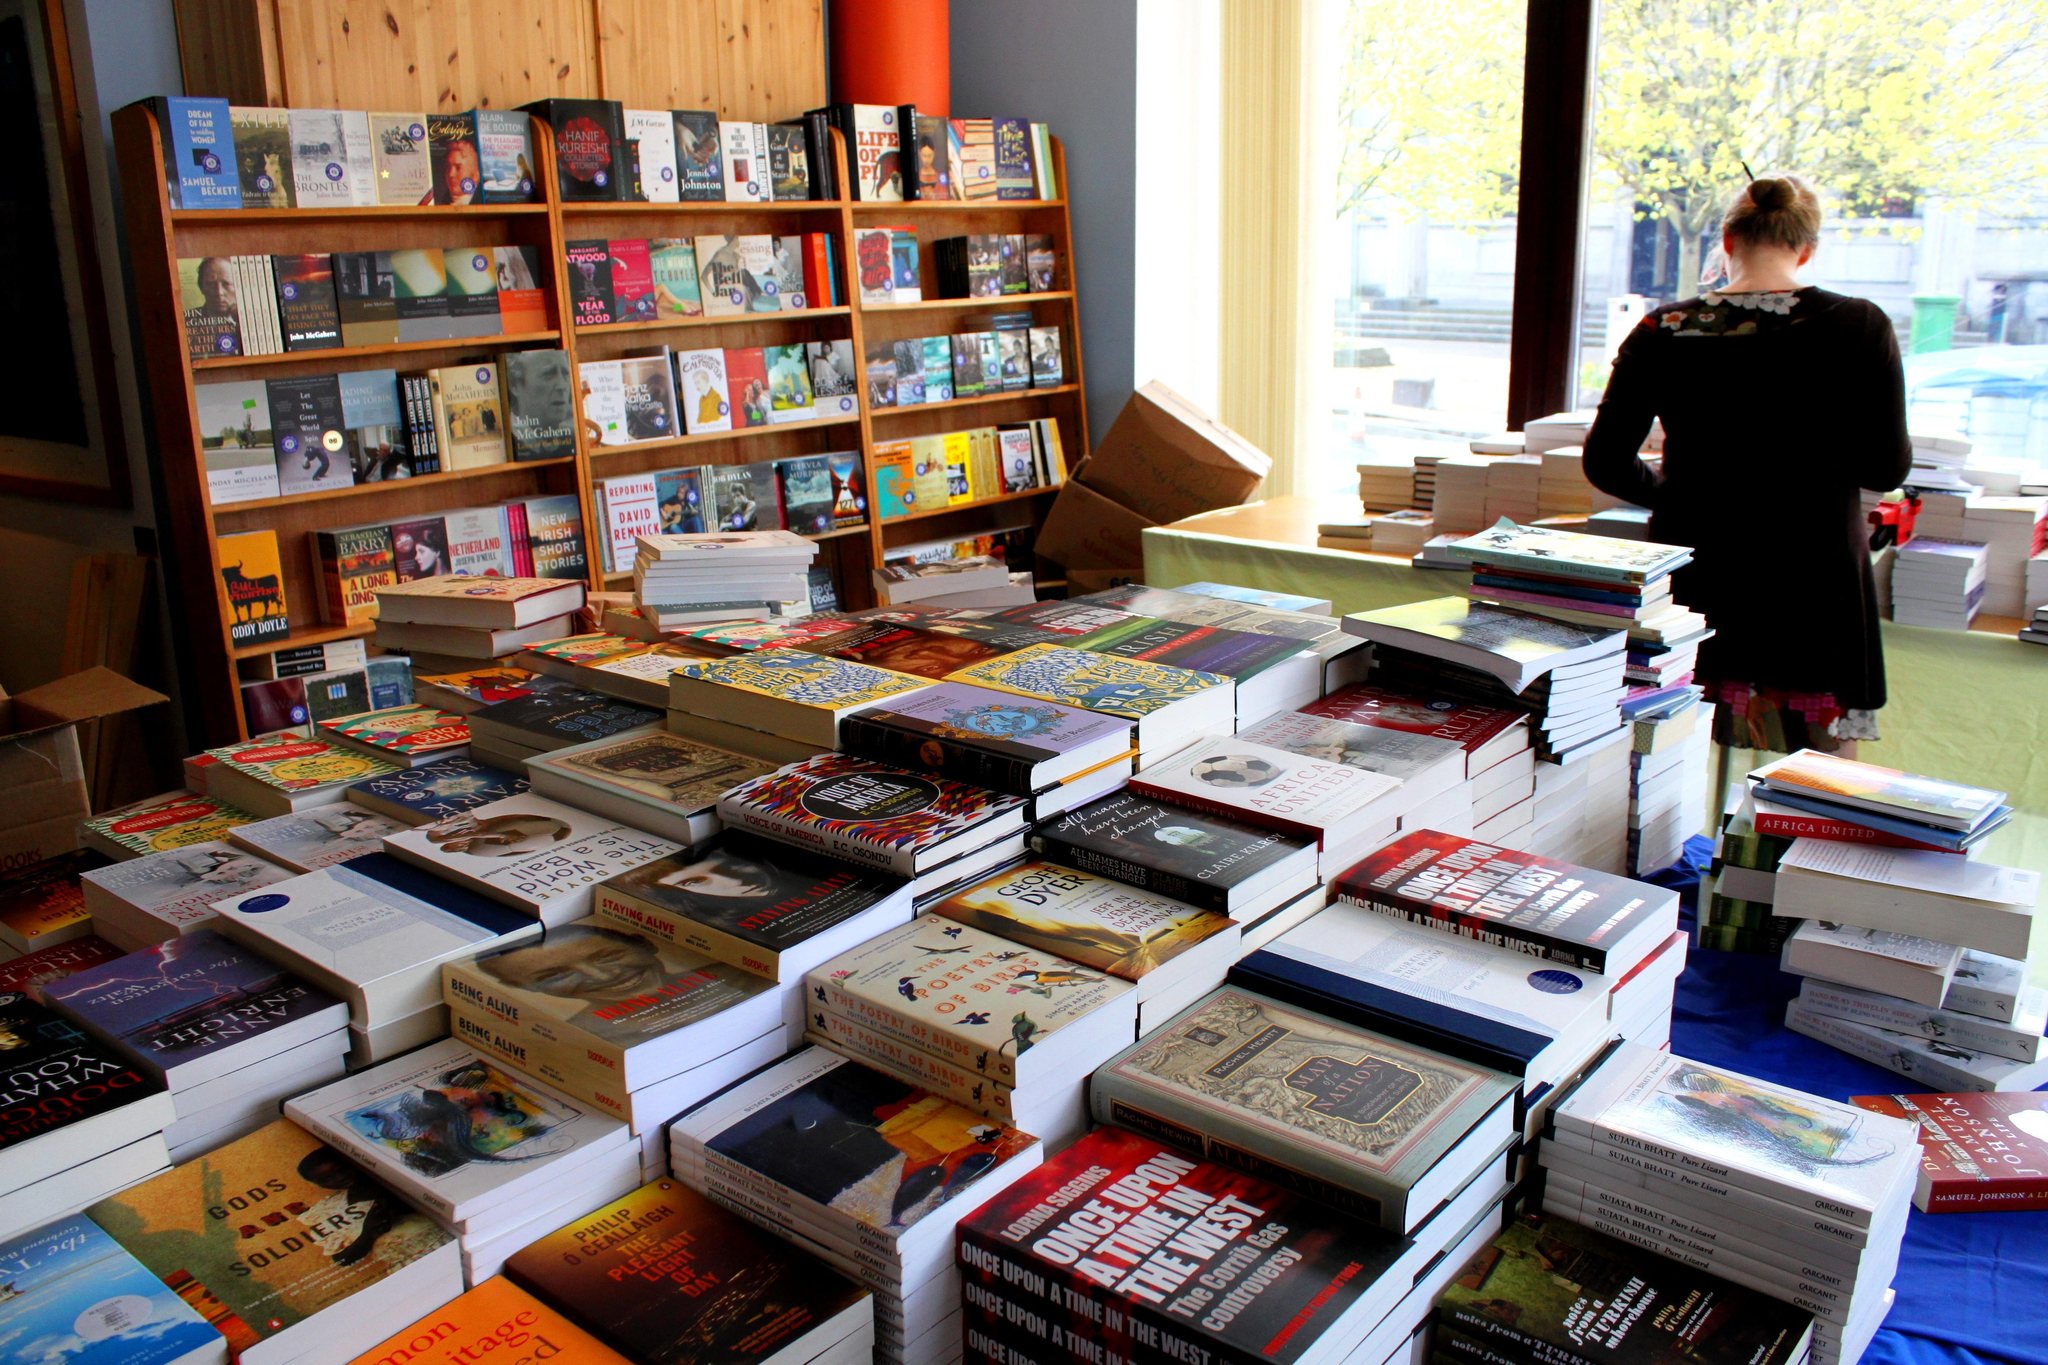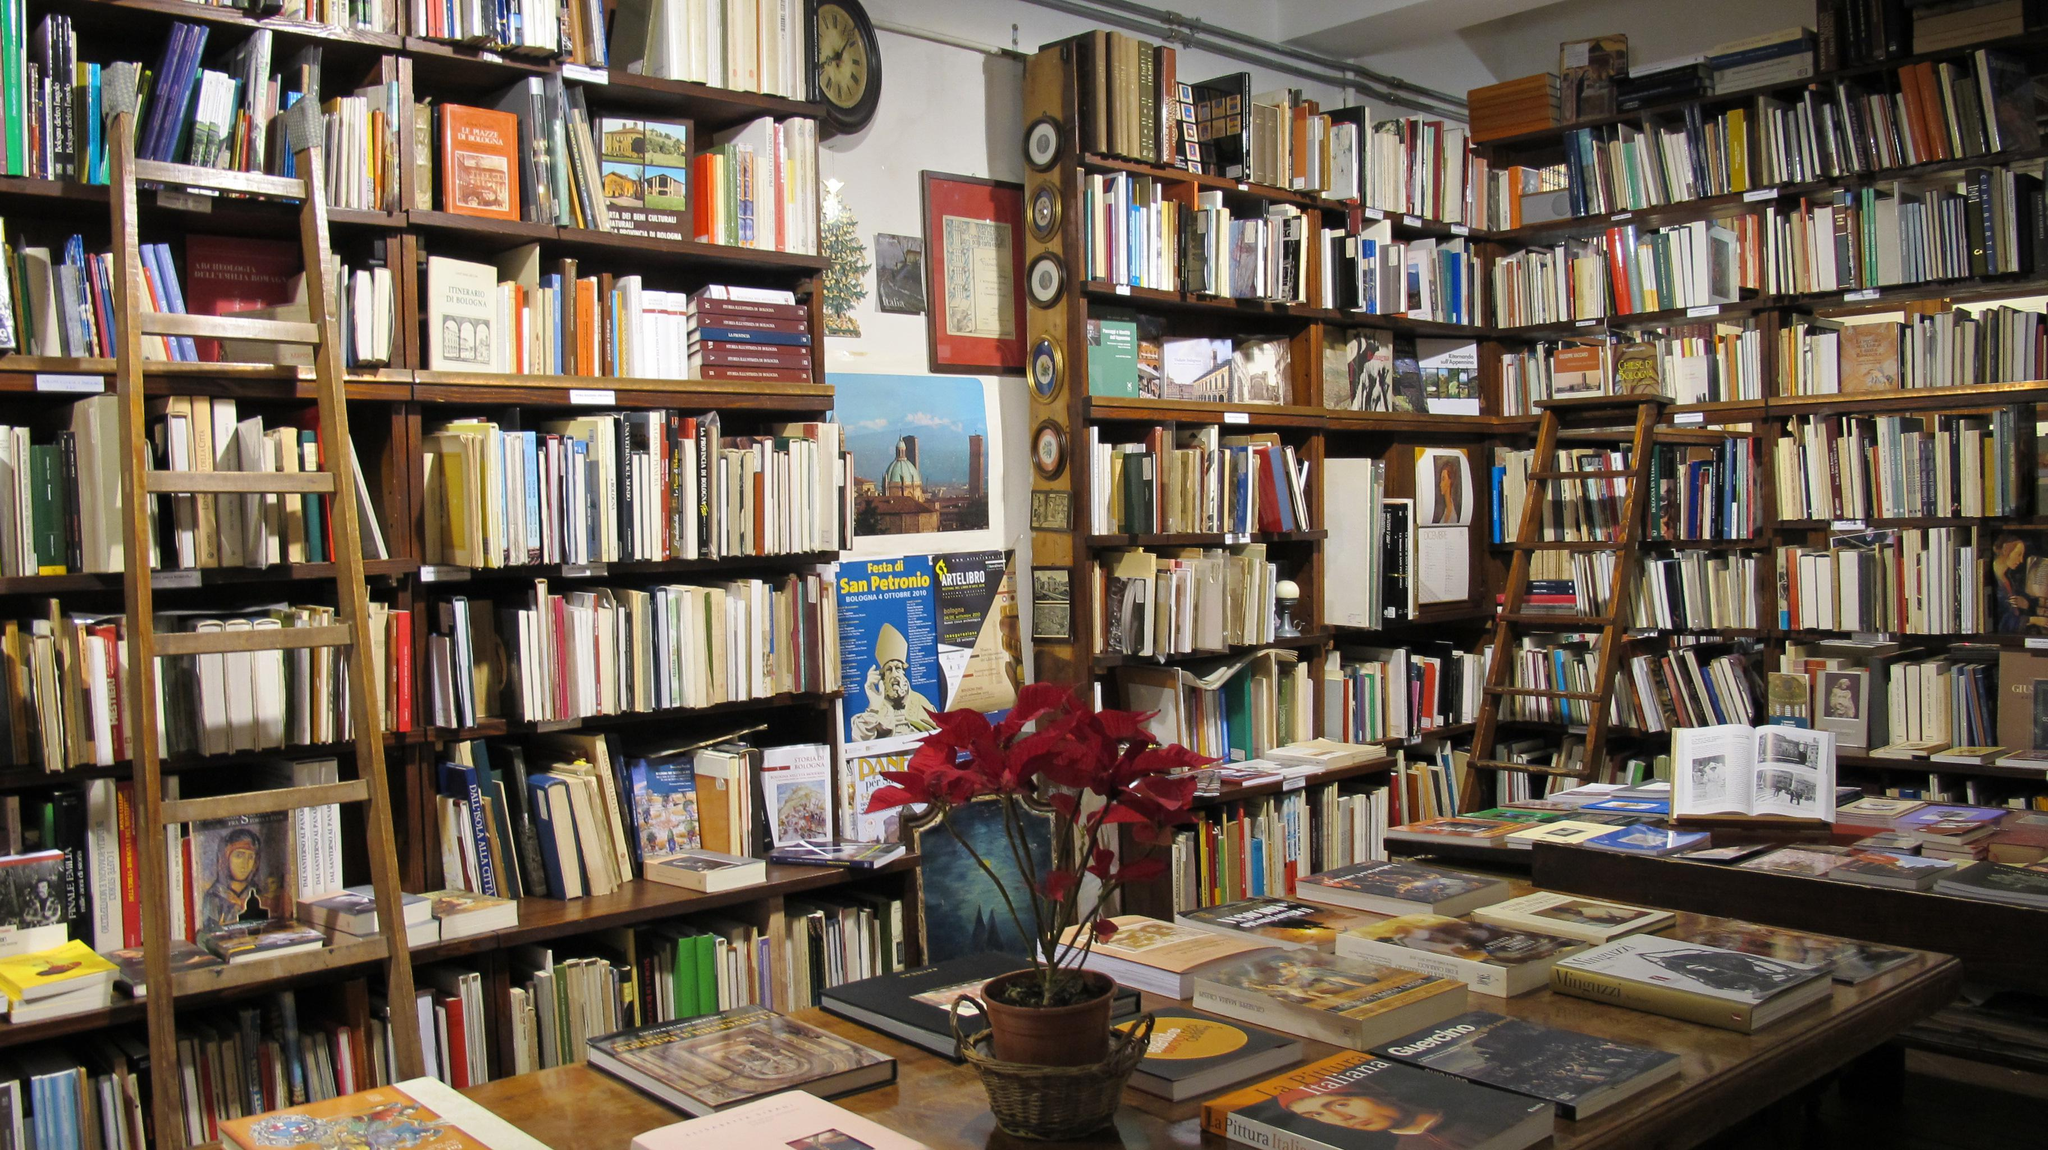The first image is the image on the left, the second image is the image on the right. For the images displayed, is the sentence "No customers can be seen in either bookshop image." factually correct? Answer yes or no. No. The first image is the image on the left, the second image is the image on the right. Evaluate the accuracy of this statement regarding the images: "A container of flowers sits on a table in one of the bookstore images.". Is it true? Answer yes or no. Yes. 